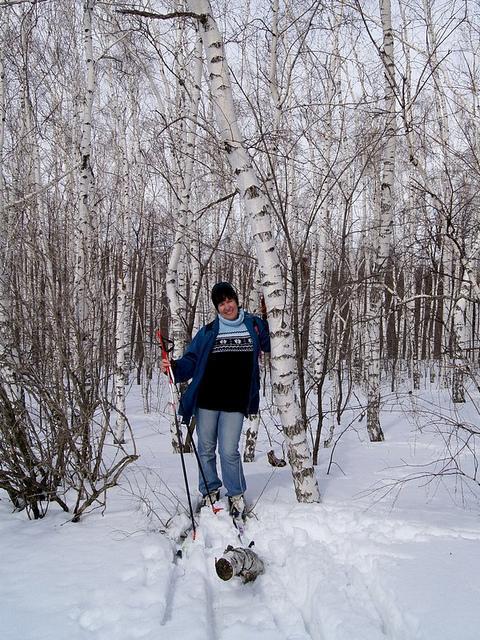How many people are there?
Give a very brief answer. 1. How many elephants are holding their trunks up in the picture?
Give a very brief answer. 0. 